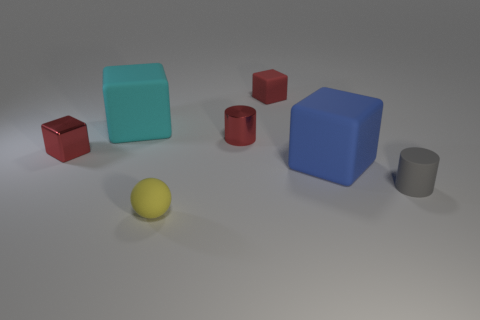What number of other objects are the same size as the shiny cylinder?
Your response must be concise. 4. How big is the gray cylinder right of the tiny rubber thing that is behind the big thing on the right side of the tiny sphere?
Ensure brevity in your answer.  Small. How big is the matte thing that is in front of the big blue rubber object and on the left side of the small gray thing?
Make the answer very short. Small. What is the shape of the red metal thing to the left of the big object that is to the left of the large thing right of the yellow sphere?
Your answer should be compact. Cube. Do the big thing behind the blue block and the tiny metallic thing that is to the left of the cyan cube have the same shape?
Provide a short and direct response. Yes. How many other things are the same material as the tiny gray thing?
Your answer should be compact. 4. There is a big blue object that is made of the same material as the yellow object; what shape is it?
Provide a short and direct response. Cube. Is the size of the rubber cylinder the same as the red metal cylinder?
Offer a very short reply. Yes. How big is the cyan block behind the cylinder left of the small gray matte cylinder?
Give a very brief answer. Large. What shape is the metal thing that is the same color as the small shiny cylinder?
Provide a short and direct response. Cube. 